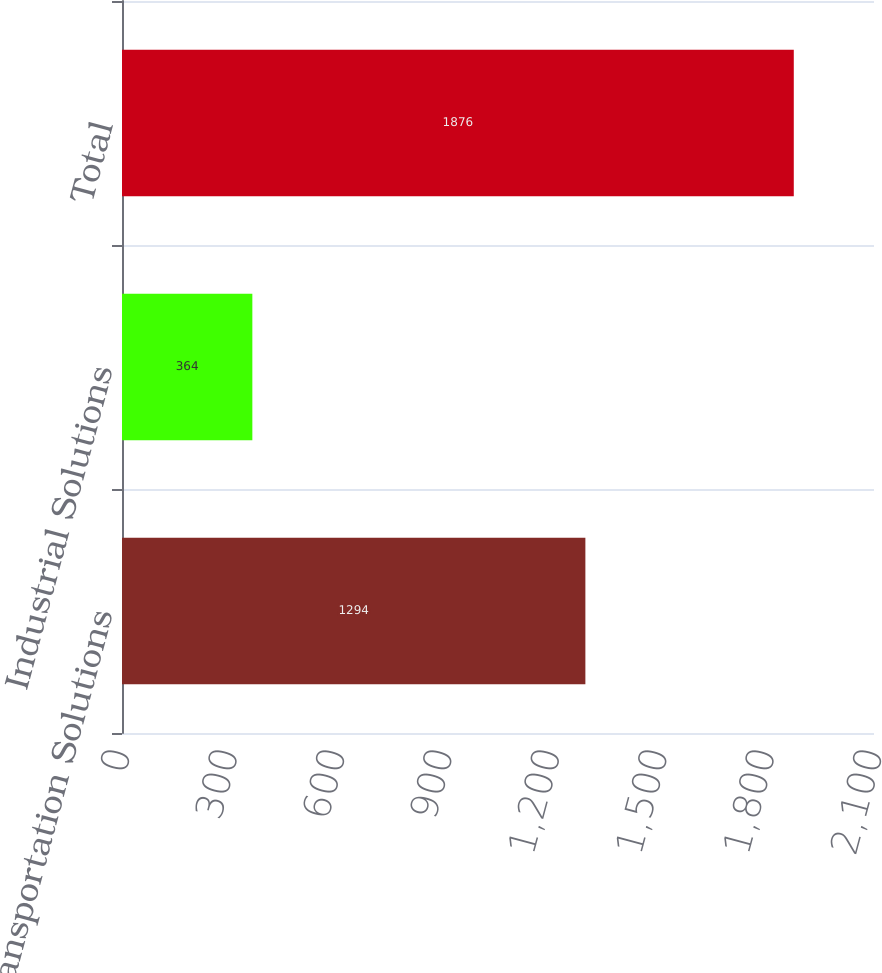Convert chart. <chart><loc_0><loc_0><loc_500><loc_500><bar_chart><fcel>Transportation Solutions<fcel>Industrial Solutions<fcel>Total<nl><fcel>1294<fcel>364<fcel>1876<nl></chart> 